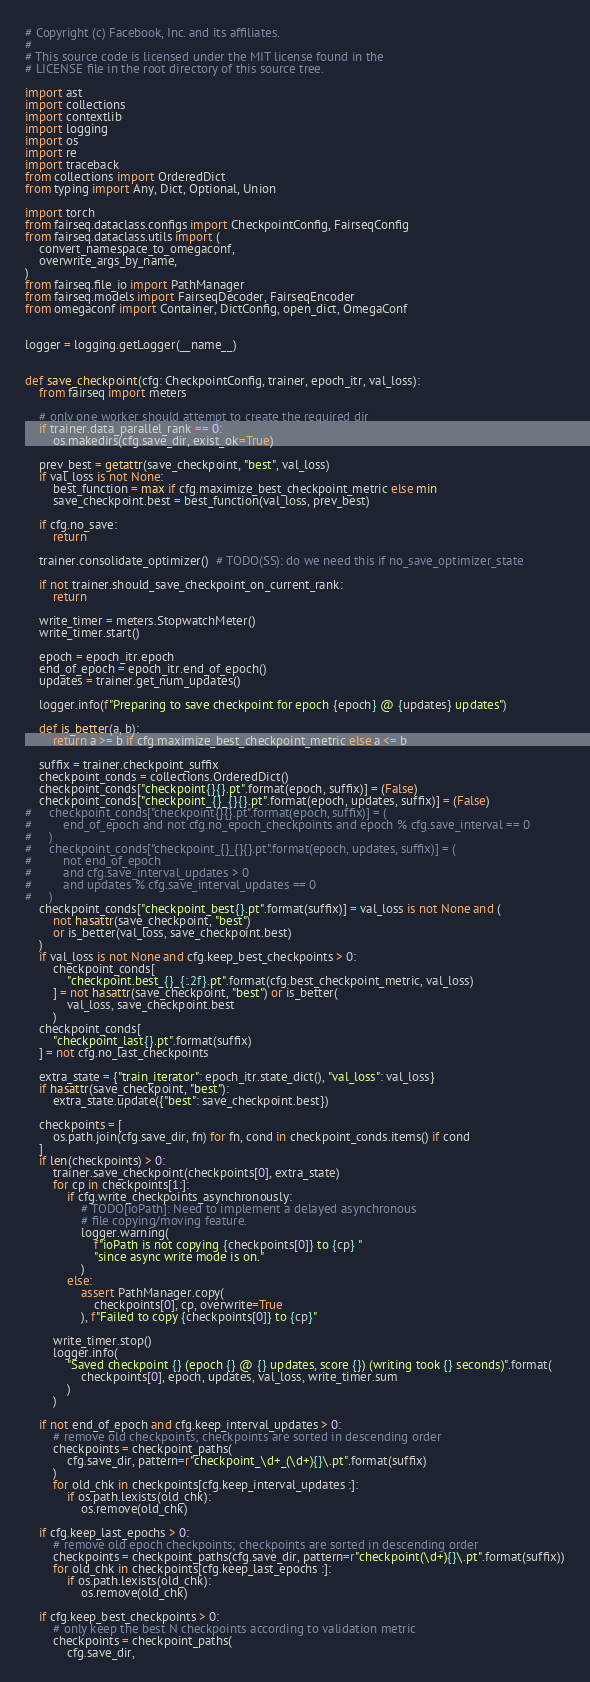Convert code to text. <code><loc_0><loc_0><loc_500><loc_500><_Python_># Copyright (c) Facebook, Inc. and its affiliates.
#
# This source code is licensed under the MIT license found in the
# LICENSE file in the root directory of this source tree.

import ast
import collections
import contextlib
import logging
import os
import re
import traceback
from collections import OrderedDict
from typing import Any, Dict, Optional, Union

import torch
from fairseq.dataclass.configs import CheckpointConfig, FairseqConfig
from fairseq.dataclass.utils import (
    convert_namespace_to_omegaconf,
    overwrite_args_by_name,
)
from fairseq.file_io import PathManager
from fairseq.models import FairseqDecoder, FairseqEncoder
from omegaconf import Container, DictConfig, open_dict, OmegaConf


logger = logging.getLogger(__name__)


def save_checkpoint(cfg: CheckpointConfig, trainer, epoch_itr, val_loss):
    from fairseq import meters

    # only one worker should attempt to create the required dir
    if trainer.data_parallel_rank == 0:
        os.makedirs(cfg.save_dir, exist_ok=True)

    prev_best = getattr(save_checkpoint, "best", val_loss)
    if val_loss is not None:
        best_function = max if cfg.maximize_best_checkpoint_metric else min
        save_checkpoint.best = best_function(val_loss, prev_best)

    if cfg.no_save:
        return

    trainer.consolidate_optimizer()  # TODO(SS): do we need this if no_save_optimizer_state

    if not trainer.should_save_checkpoint_on_current_rank:
        return

    write_timer = meters.StopwatchMeter()
    write_timer.start()

    epoch = epoch_itr.epoch
    end_of_epoch = epoch_itr.end_of_epoch()
    updates = trainer.get_num_updates()

    logger.info(f"Preparing to save checkpoint for epoch {epoch} @ {updates} updates")

    def is_better(a, b):
        return a >= b if cfg.maximize_best_checkpoint_metric else a <= b

    suffix = trainer.checkpoint_suffix
    checkpoint_conds = collections.OrderedDict()
    checkpoint_conds["checkpoint{}{}.pt".format(epoch, suffix)] = (False)
    checkpoint_conds["checkpoint_{}_{}{}.pt".format(epoch, updates, suffix)] = (False)
#     checkpoint_conds["checkpoint{}{}.pt".format(epoch, suffix)] = (
#         end_of_epoch and not cfg.no_epoch_checkpoints and epoch % cfg.save_interval == 0
#     )
#     checkpoint_conds["checkpoint_{}_{}{}.pt".format(epoch, updates, suffix)] = (
#         not end_of_epoch
#         and cfg.save_interval_updates > 0
#         and updates % cfg.save_interval_updates == 0
#     )
    checkpoint_conds["checkpoint_best{}.pt".format(suffix)] = val_loss is not None and (
        not hasattr(save_checkpoint, "best")
        or is_better(val_loss, save_checkpoint.best)
    )
    if val_loss is not None and cfg.keep_best_checkpoints > 0:
        checkpoint_conds[
            "checkpoint.best_{}_{:.2f}.pt".format(cfg.best_checkpoint_metric, val_loss)
        ] = not hasattr(save_checkpoint, "best") or is_better(
            val_loss, save_checkpoint.best
        )
    checkpoint_conds[
        "checkpoint_last{}.pt".format(suffix)
    ] = not cfg.no_last_checkpoints

    extra_state = {"train_iterator": epoch_itr.state_dict(), "val_loss": val_loss}
    if hasattr(save_checkpoint, "best"):
        extra_state.update({"best": save_checkpoint.best})

    checkpoints = [
        os.path.join(cfg.save_dir, fn) for fn, cond in checkpoint_conds.items() if cond
    ]
    if len(checkpoints) > 0:
        trainer.save_checkpoint(checkpoints[0], extra_state)
        for cp in checkpoints[1:]:
            if cfg.write_checkpoints_asynchronously:
                # TODO[ioPath]: Need to implement a delayed asynchronous
                # file copying/moving feature.
                logger.warning(
                    f"ioPath is not copying {checkpoints[0]} to {cp} "
                    "since async write mode is on."
                )
            else:
                assert PathManager.copy(
                    checkpoints[0], cp, overwrite=True
                ), f"Failed to copy {checkpoints[0]} to {cp}"

        write_timer.stop()
        logger.info(
            "Saved checkpoint {} (epoch {} @ {} updates, score {}) (writing took {} seconds)".format(
                checkpoints[0], epoch, updates, val_loss, write_timer.sum
            )
        )

    if not end_of_epoch and cfg.keep_interval_updates > 0:
        # remove old checkpoints; checkpoints are sorted in descending order
        checkpoints = checkpoint_paths(
            cfg.save_dir, pattern=r"checkpoint_\d+_(\d+){}\.pt".format(suffix)
        )
        for old_chk in checkpoints[cfg.keep_interval_updates :]:
            if os.path.lexists(old_chk):
                os.remove(old_chk)

    if cfg.keep_last_epochs > 0:
        # remove old epoch checkpoints; checkpoints are sorted in descending order
        checkpoints = checkpoint_paths(cfg.save_dir, pattern=r"checkpoint(\d+){}\.pt".format(suffix))
        for old_chk in checkpoints[cfg.keep_last_epochs :]:
            if os.path.lexists(old_chk):
                os.remove(old_chk)

    if cfg.keep_best_checkpoints > 0:
        # only keep the best N checkpoints according to validation metric
        checkpoints = checkpoint_paths(
            cfg.save_dir,</code> 